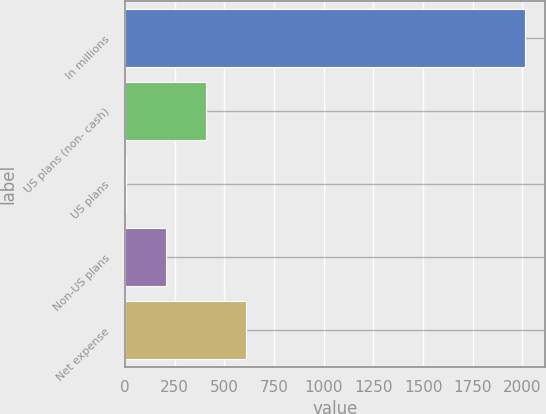<chart> <loc_0><loc_0><loc_500><loc_500><bar_chart><fcel>In millions<fcel>US plans (non- cash)<fcel>US plans<fcel>Non-US plans<fcel>Net expense<nl><fcel>2014<fcel>408.4<fcel>7<fcel>207.7<fcel>609.1<nl></chart> 